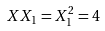<formula> <loc_0><loc_0><loc_500><loc_500>X X _ { 1 } = X _ { 1 } ^ { 2 } = 4</formula> 